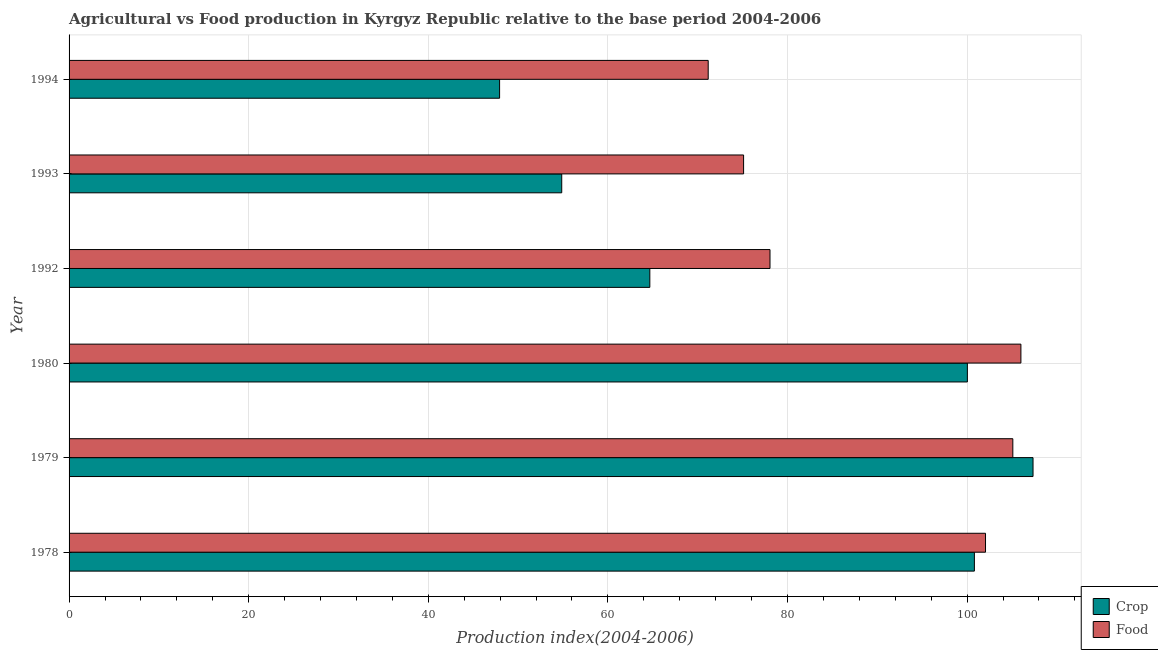Are the number of bars per tick equal to the number of legend labels?
Your response must be concise. Yes. How many bars are there on the 3rd tick from the top?
Offer a terse response. 2. How many bars are there on the 6th tick from the bottom?
Give a very brief answer. 2. In how many cases, is the number of bars for a given year not equal to the number of legend labels?
Provide a short and direct response. 0. What is the crop production index in 1979?
Provide a short and direct response. 107.34. Across all years, what is the maximum food production index?
Ensure brevity in your answer.  105.99. Across all years, what is the minimum food production index?
Keep it short and to the point. 71.17. In which year was the crop production index maximum?
Make the answer very short. 1979. In which year was the food production index minimum?
Your answer should be compact. 1994. What is the total crop production index in the graph?
Your response must be concise. 475.65. What is the difference between the crop production index in 1979 and that in 1992?
Keep it short and to the point. 42.67. What is the difference between the food production index in 1994 and the crop production index in 1993?
Provide a succinct answer. 16.31. What is the average crop production index per year?
Your answer should be very brief. 79.28. In the year 1980, what is the difference between the crop production index and food production index?
Offer a very short reply. -5.96. In how many years, is the crop production index greater than 68 ?
Make the answer very short. 3. What is the ratio of the food production index in 1979 to that in 1992?
Your response must be concise. 1.35. Is the crop production index in 1979 less than that in 1992?
Offer a terse response. No. What is the difference between the highest and the lowest crop production index?
Make the answer very short. 59.4. In how many years, is the food production index greater than the average food production index taken over all years?
Offer a very short reply. 3. Is the sum of the food production index in 1978 and 1992 greater than the maximum crop production index across all years?
Make the answer very short. Yes. What does the 2nd bar from the top in 1993 represents?
Your answer should be very brief. Crop. What does the 2nd bar from the bottom in 1992 represents?
Keep it short and to the point. Food. How many years are there in the graph?
Keep it short and to the point. 6. Are the values on the major ticks of X-axis written in scientific E-notation?
Provide a short and direct response. No. Where does the legend appear in the graph?
Provide a short and direct response. Bottom right. How many legend labels are there?
Provide a short and direct response. 2. What is the title of the graph?
Keep it short and to the point. Agricultural vs Food production in Kyrgyz Republic relative to the base period 2004-2006. Does "Gasoline" appear as one of the legend labels in the graph?
Your response must be concise. No. What is the label or title of the X-axis?
Ensure brevity in your answer.  Production index(2004-2006). What is the Production index(2004-2006) of Crop in 1978?
Your answer should be very brief. 100.81. What is the Production index(2004-2006) in Food in 1978?
Offer a terse response. 102.05. What is the Production index(2004-2006) of Crop in 1979?
Keep it short and to the point. 107.34. What is the Production index(2004-2006) of Food in 1979?
Give a very brief answer. 105.09. What is the Production index(2004-2006) of Crop in 1980?
Your answer should be compact. 100.03. What is the Production index(2004-2006) of Food in 1980?
Provide a short and direct response. 105.99. What is the Production index(2004-2006) of Crop in 1992?
Offer a terse response. 64.67. What is the Production index(2004-2006) in Food in 1992?
Your answer should be compact. 78.05. What is the Production index(2004-2006) in Crop in 1993?
Ensure brevity in your answer.  54.86. What is the Production index(2004-2006) in Food in 1993?
Make the answer very short. 75.11. What is the Production index(2004-2006) of Crop in 1994?
Ensure brevity in your answer.  47.94. What is the Production index(2004-2006) of Food in 1994?
Offer a terse response. 71.17. Across all years, what is the maximum Production index(2004-2006) of Crop?
Ensure brevity in your answer.  107.34. Across all years, what is the maximum Production index(2004-2006) in Food?
Give a very brief answer. 105.99. Across all years, what is the minimum Production index(2004-2006) in Crop?
Your response must be concise. 47.94. Across all years, what is the minimum Production index(2004-2006) in Food?
Your answer should be compact. 71.17. What is the total Production index(2004-2006) in Crop in the graph?
Give a very brief answer. 475.65. What is the total Production index(2004-2006) in Food in the graph?
Make the answer very short. 537.46. What is the difference between the Production index(2004-2006) of Crop in 1978 and that in 1979?
Your answer should be compact. -6.53. What is the difference between the Production index(2004-2006) in Food in 1978 and that in 1979?
Provide a short and direct response. -3.04. What is the difference between the Production index(2004-2006) in Crop in 1978 and that in 1980?
Provide a short and direct response. 0.78. What is the difference between the Production index(2004-2006) in Food in 1978 and that in 1980?
Offer a terse response. -3.94. What is the difference between the Production index(2004-2006) in Crop in 1978 and that in 1992?
Offer a very short reply. 36.14. What is the difference between the Production index(2004-2006) in Crop in 1978 and that in 1993?
Your answer should be compact. 45.95. What is the difference between the Production index(2004-2006) in Food in 1978 and that in 1993?
Offer a terse response. 26.94. What is the difference between the Production index(2004-2006) in Crop in 1978 and that in 1994?
Give a very brief answer. 52.87. What is the difference between the Production index(2004-2006) of Food in 1978 and that in 1994?
Your response must be concise. 30.88. What is the difference between the Production index(2004-2006) in Crop in 1979 and that in 1980?
Provide a short and direct response. 7.31. What is the difference between the Production index(2004-2006) in Food in 1979 and that in 1980?
Keep it short and to the point. -0.9. What is the difference between the Production index(2004-2006) of Crop in 1979 and that in 1992?
Offer a very short reply. 42.67. What is the difference between the Production index(2004-2006) in Food in 1979 and that in 1992?
Give a very brief answer. 27.04. What is the difference between the Production index(2004-2006) of Crop in 1979 and that in 1993?
Provide a short and direct response. 52.48. What is the difference between the Production index(2004-2006) of Food in 1979 and that in 1993?
Ensure brevity in your answer.  29.98. What is the difference between the Production index(2004-2006) of Crop in 1979 and that in 1994?
Keep it short and to the point. 59.4. What is the difference between the Production index(2004-2006) in Food in 1979 and that in 1994?
Provide a short and direct response. 33.92. What is the difference between the Production index(2004-2006) in Crop in 1980 and that in 1992?
Provide a short and direct response. 35.36. What is the difference between the Production index(2004-2006) of Food in 1980 and that in 1992?
Offer a terse response. 27.94. What is the difference between the Production index(2004-2006) of Crop in 1980 and that in 1993?
Make the answer very short. 45.17. What is the difference between the Production index(2004-2006) in Food in 1980 and that in 1993?
Give a very brief answer. 30.88. What is the difference between the Production index(2004-2006) in Crop in 1980 and that in 1994?
Keep it short and to the point. 52.09. What is the difference between the Production index(2004-2006) in Food in 1980 and that in 1994?
Your answer should be very brief. 34.82. What is the difference between the Production index(2004-2006) in Crop in 1992 and that in 1993?
Offer a very short reply. 9.81. What is the difference between the Production index(2004-2006) of Food in 1992 and that in 1993?
Offer a very short reply. 2.94. What is the difference between the Production index(2004-2006) of Crop in 1992 and that in 1994?
Offer a terse response. 16.73. What is the difference between the Production index(2004-2006) of Food in 1992 and that in 1994?
Your answer should be compact. 6.88. What is the difference between the Production index(2004-2006) in Crop in 1993 and that in 1994?
Your answer should be compact. 6.92. What is the difference between the Production index(2004-2006) of Food in 1993 and that in 1994?
Provide a succinct answer. 3.94. What is the difference between the Production index(2004-2006) of Crop in 1978 and the Production index(2004-2006) of Food in 1979?
Ensure brevity in your answer.  -4.28. What is the difference between the Production index(2004-2006) in Crop in 1978 and the Production index(2004-2006) in Food in 1980?
Offer a terse response. -5.18. What is the difference between the Production index(2004-2006) of Crop in 1978 and the Production index(2004-2006) of Food in 1992?
Provide a succinct answer. 22.76. What is the difference between the Production index(2004-2006) of Crop in 1978 and the Production index(2004-2006) of Food in 1993?
Give a very brief answer. 25.7. What is the difference between the Production index(2004-2006) in Crop in 1978 and the Production index(2004-2006) in Food in 1994?
Give a very brief answer. 29.64. What is the difference between the Production index(2004-2006) in Crop in 1979 and the Production index(2004-2006) in Food in 1980?
Provide a short and direct response. 1.35. What is the difference between the Production index(2004-2006) of Crop in 1979 and the Production index(2004-2006) of Food in 1992?
Your response must be concise. 29.29. What is the difference between the Production index(2004-2006) of Crop in 1979 and the Production index(2004-2006) of Food in 1993?
Keep it short and to the point. 32.23. What is the difference between the Production index(2004-2006) of Crop in 1979 and the Production index(2004-2006) of Food in 1994?
Make the answer very short. 36.17. What is the difference between the Production index(2004-2006) in Crop in 1980 and the Production index(2004-2006) in Food in 1992?
Keep it short and to the point. 21.98. What is the difference between the Production index(2004-2006) in Crop in 1980 and the Production index(2004-2006) in Food in 1993?
Provide a succinct answer. 24.92. What is the difference between the Production index(2004-2006) of Crop in 1980 and the Production index(2004-2006) of Food in 1994?
Ensure brevity in your answer.  28.86. What is the difference between the Production index(2004-2006) of Crop in 1992 and the Production index(2004-2006) of Food in 1993?
Make the answer very short. -10.44. What is the difference between the Production index(2004-2006) in Crop in 1993 and the Production index(2004-2006) in Food in 1994?
Your answer should be compact. -16.31. What is the average Production index(2004-2006) of Crop per year?
Ensure brevity in your answer.  79.28. What is the average Production index(2004-2006) of Food per year?
Offer a very short reply. 89.58. In the year 1978, what is the difference between the Production index(2004-2006) of Crop and Production index(2004-2006) of Food?
Provide a short and direct response. -1.24. In the year 1979, what is the difference between the Production index(2004-2006) in Crop and Production index(2004-2006) in Food?
Your answer should be compact. 2.25. In the year 1980, what is the difference between the Production index(2004-2006) of Crop and Production index(2004-2006) of Food?
Make the answer very short. -5.96. In the year 1992, what is the difference between the Production index(2004-2006) in Crop and Production index(2004-2006) in Food?
Provide a succinct answer. -13.38. In the year 1993, what is the difference between the Production index(2004-2006) in Crop and Production index(2004-2006) in Food?
Provide a succinct answer. -20.25. In the year 1994, what is the difference between the Production index(2004-2006) in Crop and Production index(2004-2006) in Food?
Offer a terse response. -23.23. What is the ratio of the Production index(2004-2006) in Crop in 1978 to that in 1979?
Your answer should be very brief. 0.94. What is the ratio of the Production index(2004-2006) of Food in 1978 to that in 1979?
Your response must be concise. 0.97. What is the ratio of the Production index(2004-2006) of Crop in 1978 to that in 1980?
Give a very brief answer. 1.01. What is the ratio of the Production index(2004-2006) in Food in 1978 to that in 1980?
Give a very brief answer. 0.96. What is the ratio of the Production index(2004-2006) in Crop in 1978 to that in 1992?
Keep it short and to the point. 1.56. What is the ratio of the Production index(2004-2006) in Food in 1978 to that in 1992?
Your answer should be compact. 1.31. What is the ratio of the Production index(2004-2006) of Crop in 1978 to that in 1993?
Provide a succinct answer. 1.84. What is the ratio of the Production index(2004-2006) of Food in 1978 to that in 1993?
Your answer should be very brief. 1.36. What is the ratio of the Production index(2004-2006) of Crop in 1978 to that in 1994?
Offer a terse response. 2.1. What is the ratio of the Production index(2004-2006) in Food in 1978 to that in 1994?
Offer a very short reply. 1.43. What is the ratio of the Production index(2004-2006) in Crop in 1979 to that in 1980?
Your response must be concise. 1.07. What is the ratio of the Production index(2004-2006) in Crop in 1979 to that in 1992?
Provide a short and direct response. 1.66. What is the ratio of the Production index(2004-2006) of Food in 1979 to that in 1992?
Give a very brief answer. 1.35. What is the ratio of the Production index(2004-2006) in Crop in 1979 to that in 1993?
Keep it short and to the point. 1.96. What is the ratio of the Production index(2004-2006) of Food in 1979 to that in 1993?
Make the answer very short. 1.4. What is the ratio of the Production index(2004-2006) of Crop in 1979 to that in 1994?
Make the answer very short. 2.24. What is the ratio of the Production index(2004-2006) of Food in 1979 to that in 1994?
Offer a very short reply. 1.48. What is the ratio of the Production index(2004-2006) in Crop in 1980 to that in 1992?
Make the answer very short. 1.55. What is the ratio of the Production index(2004-2006) of Food in 1980 to that in 1992?
Provide a short and direct response. 1.36. What is the ratio of the Production index(2004-2006) of Crop in 1980 to that in 1993?
Provide a succinct answer. 1.82. What is the ratio of the Production index(2004-2006) of Food in 1980 to that in 1993?
Offer a terse response. 1.41. What is the ratio of the Production index(2004-2006) of Crop in 1980 to that in 1994?
Your response must be concise. 2.09. What is the ratio of the Production index(2004-2006) in Food in 1980 to that in 1994?
Ensure brevity in your answer.  1.49. What is the ratio of the Production index(2004-2006) of Crop in 1992 to that in 1993?
Make the answer very short. 1.18. What is the ratio of the Production index(2004-2006) of Food in 1992 to that in 1993?
Give a very brief answer. 1.04. What is the ratio of the Production index(2004-2006) in Crop in 1992 to that in 1994?
Your answer should be compact. 1.35. What is the ratio of the Production index(2004-2006) in Food in 1992 to that in 1994?
Your answer should be compact. 1.1. What is the ratio of the Production index(2004-2006) of Crop in 1993 to that in 1994?
Ensure brevity in your answer.  1.14. What is the ratio of the Production index(2004-2006) in Food in 1993 to that in 1994?
Ensure brevity in your answer.  1.06. What is the difference between the highest and the second highest Production index(2004-2006) of Crop?
Ensure brevity in your answer.  6.53. What is the difference between the highest and the lowest Production index(2004-2006) of Crop?
Offer a terse response. 59.4. What is the difference between the highest and the lowest Production index(2004-2006) of Food?
Offer a terse response. 34.82. 